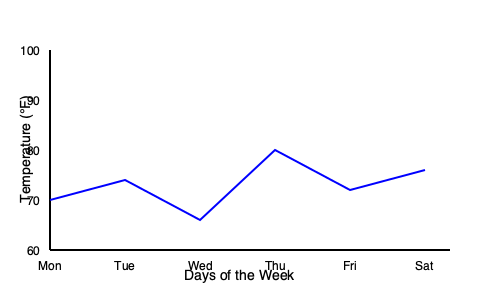As a new student in Stockton, you're interested in understanding the local weather patterns. The line graph shows the daily temperatures in Stockton for a week. Calculate the average daily temperature for the week based on the given data. To calculate the average daily temperature for the week, we need to follow these steps:

1. Identify the temperature for each day from the graph:
   Monday: 70°F
   Tuesday: 74°F
   Wednesday: 66°F
   Thursday: 80°F
   Friday: 72°F
   Saturday: 76°F

2. Sum up all the temperatures:
   $70 + 74 + 66 + 80 + 72 + 76 = 438°F$

3. Count the total number of days: 6 days

4. Calculate the average by dividing the sum by the number of days:
   $\text{Average} = \frac{\text{Sum of temperatures}}{\text{Number of days}} = \frac{438}{6} = 73°F$

Therefore, the average daily temperature for the week in Stockton is 73°F.
Answer: 73°F 